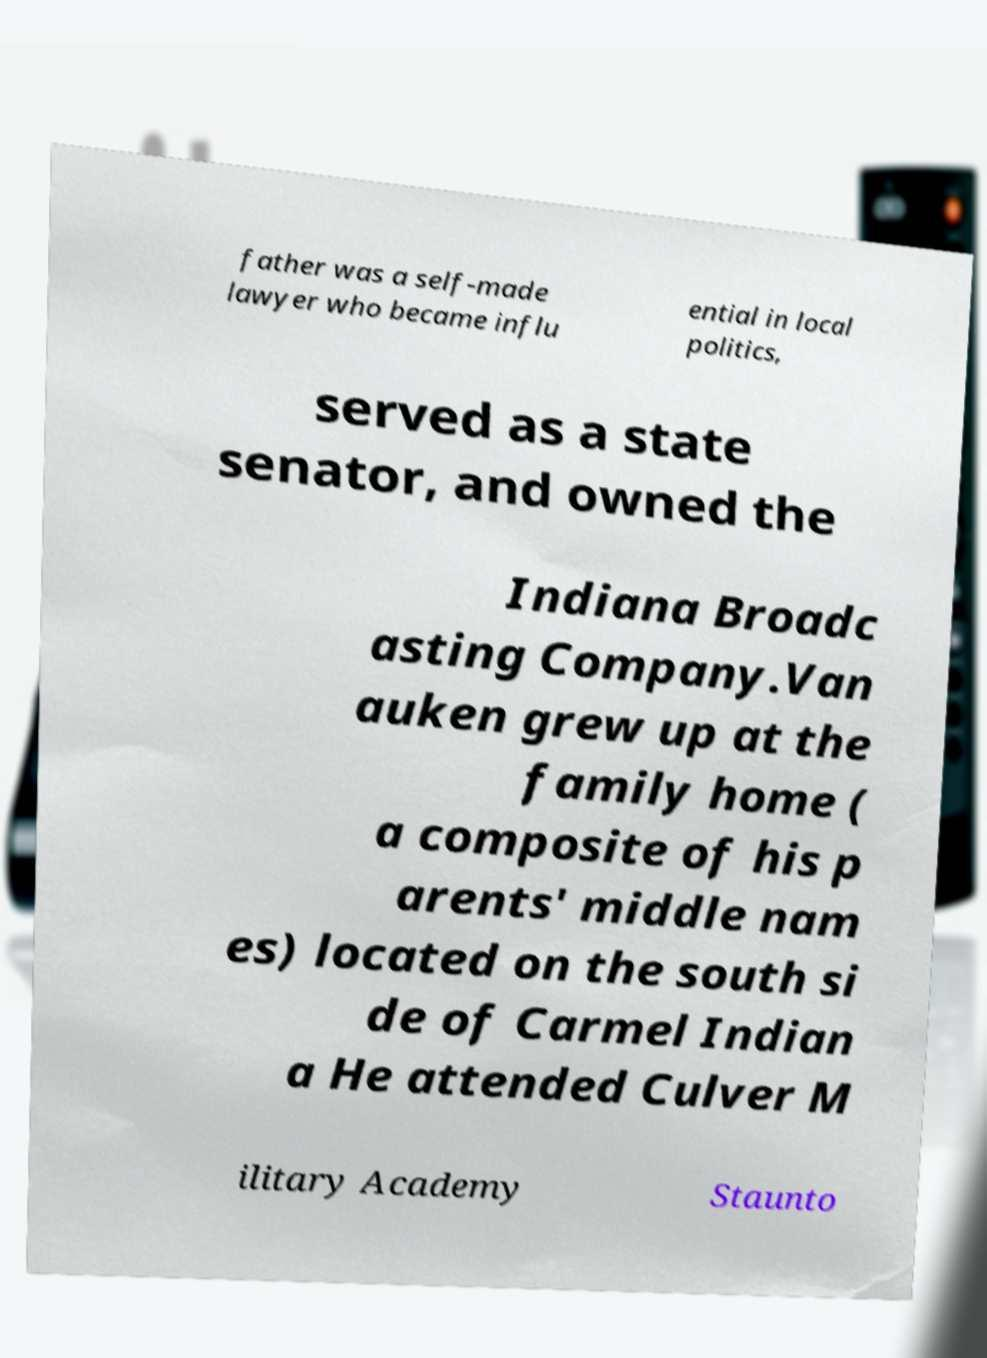For documentation purposes, I need the text within this image transcribed. Could you provide that? father was a self-made lawyer who became influ ential in local politics, served as a state senator, and owned the Indiana Broadc asting Company.Van auken grew up at the family home ( a composite of his p arents' middle nam es) located on the south si de of Carmel Indian a He attended Culver M ilitary Academy Staunto 